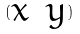Convert formula to latex. <formula><loc_0><loc_0><loc_500><loc_500>( \begin{matrix} x & y \end{matrix} )</formula> 